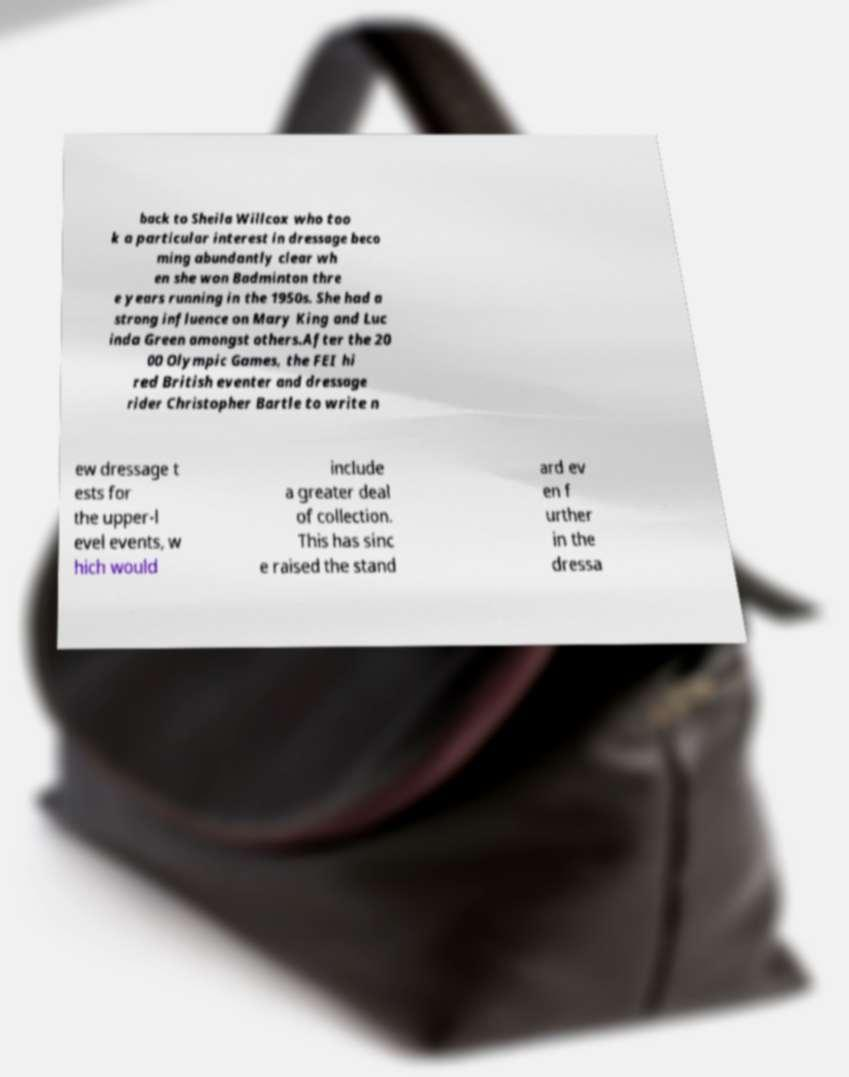I need the written content from this picture converted into text. Can you do that? back to Sheila Willcox who too k a particular interest in dressage beco ming abundantly clear wh en she won Badminton thre e years running in the 1950s. She had a strong influence on Mary King and Luc inda Green amongst others.After the 20 00 Olympic Games, the FEI hi red British eventer and dressage rider Christopher Bartle to write n ew dressage t ests for the upper-l evel events, w hich would include a greater deal of collection. This has sinc e raised the stand ard ev en f urther in the dressa 